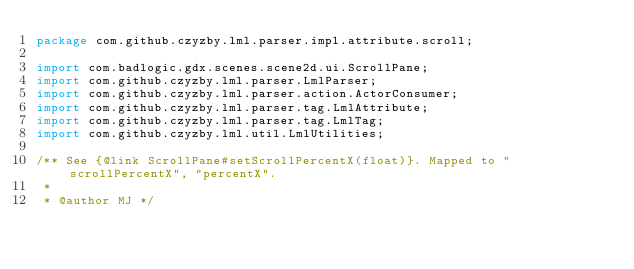Convert code to text. <code><loc_0><loc_0><loc_500><loc_500><_Java_>package com.github.czyzby.lml.parser.impl.attribute.scroll;

import com.badlogic.gdx.scenes.scene2d.ui.ScrollPane;
import com.github.czyzby.lml.parser.LmlParser;
import com.github.czyzby.lml.parser.action.ActorConsumer;
import com.github.czyzby.lml.parser.tag.LmlAttribute;
import com.github.czyzby.lml.parser.tag.LmlTag;
import com.github.czyzby.lml.util.LmlUtilities;

/** See {@link ScrollPane#setScrollPercentX(float)}. Mapped to "scrollPercentX", "percentX".
 *
 * @author MJ */</code> 